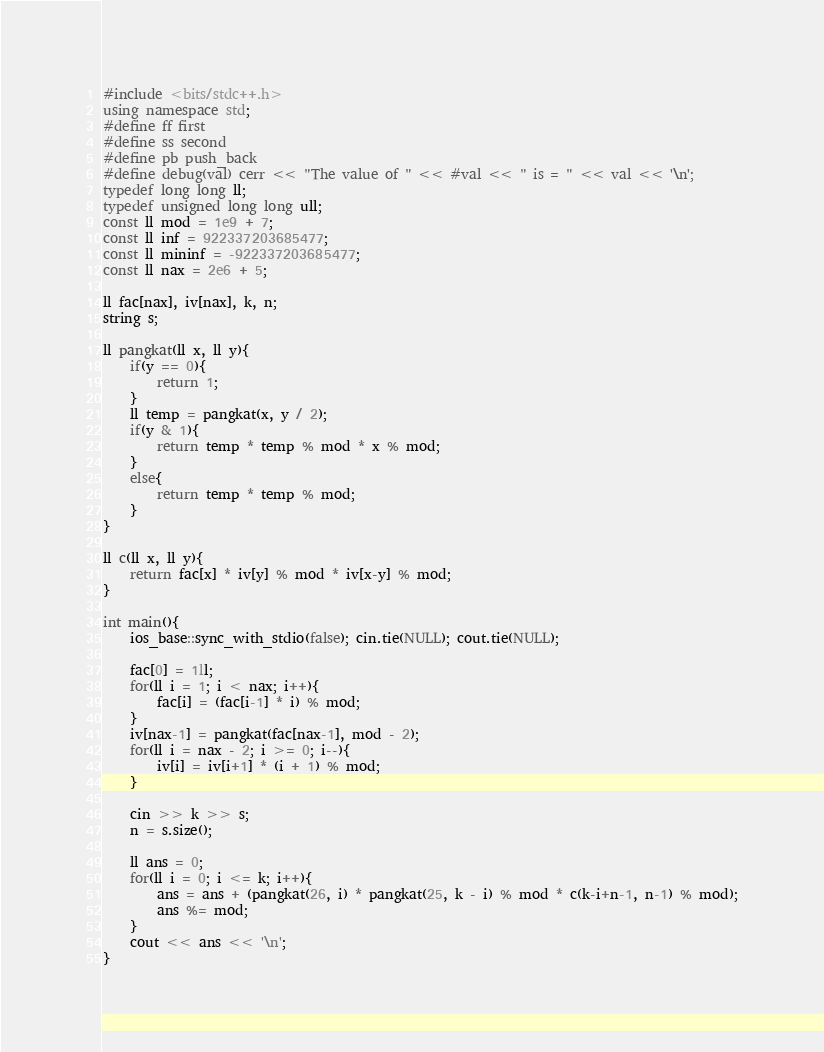<code> <loc_0><loc_0><loc_500><loc_500><_C++_>#include <bits/stdc++.h>
using namespace std;
#define ff first
#define ss second
#define pb push_back
#define debug(val) cerr << "The value of " << #val << " is = " << val << '\n';
typedef long long ll;
typedef unsigned long long ull;
const ll mod = 1e9 + 7;
const ll inf = 922337203685477;
const ll mininf = -922337203685477;
const ll nax = 2e6 + 5;

ll fac[nax], iv[nax], k, n;
string s;

ll pangkat(ll x, ll y){
	if(y == 0){
		return 1;
	}
	ll temp = pangkat(x, y / 2);
	if(y & 1){
		return temp * temp % mod * x % mod;
	}
	else{
		return temp * temp % mod;
	}
}

ll c(ll x, ll y){
	return fac[x] * iv[y] % mod * iv[x-y] % mod;
}

int main(){
	ios_base::sync_with_stdio(false); cin.tie(NULL); cout.tie(NULL);
	
	fac[0] = 1ll;
	for(ll i = 1; i < nax; i++){
		fac[i] = (fac[i-1] * i) % mod;
	}
	iv[nax-1] = pangkat(fac[nax-1], mod - 2);
	for(ll i = nax - 2; i >= 0; i--){
		iv[i] = iv[i+1] * (i + 1) % mod;
	}
	
	cin >> k >> s;
	n = s.size();
	
	ll ans = 0;
	for(ll i = 0; i <= k; i++){
		ans = ans + (pangkat(26, i) * pangkat(25, k - i) % mod * c(k-i+n-1, n-1) % mod);
		ans %= mod;
	}
	cout << ans << '\n';
}
</code> 